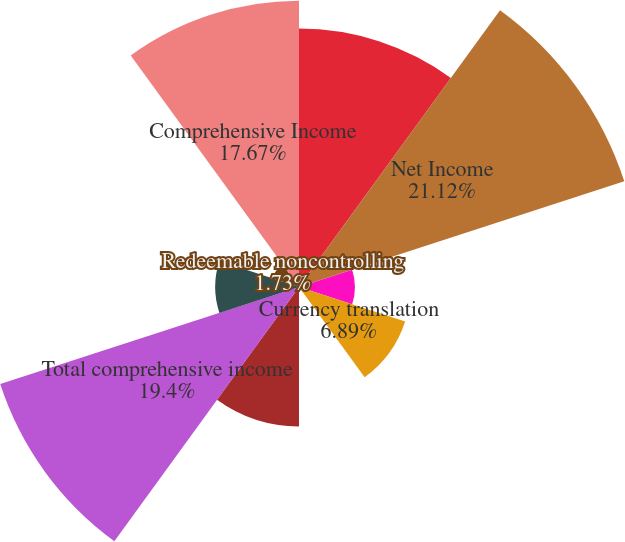<chart> <loc_0><loc_0><loc_500><loc_500><pie_chart><fcel>for the fiscal years ended<fcel>Net Income<fcel>Net unrealized losses on<fcel>Currency translation<fcel>Net unrealized gains (losses)<fcel>Total other comprehensive loss<fcel>Total comprehensive income<fcel>Nonredeemable noncontrolling<fcel>Redeemable noncontrolling<fcel>Comprehensive Income<nl><fcel>15.95%<fcel>21.11%<fcel>3.45%<fcel>6.89%<fcel>0.01%<fcel>8.61%<fcel>19.39%<fcel>5.17%<fcel>1.73%<fcel>17.67%<nl></chart> 